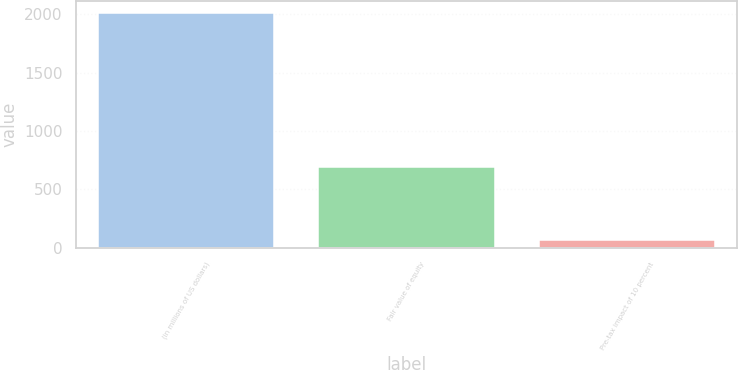Convert chart to OTSL. <chart><loc_0><loc_0><loc_500><loc_500><bar_chart><fcel>(in millions of US dollars)<fcel>Fair value of equity<fcel>Pre-tax impact of 10 percent<nl><fcel>2010<fcel>692<fcel>69<nl></chart> 